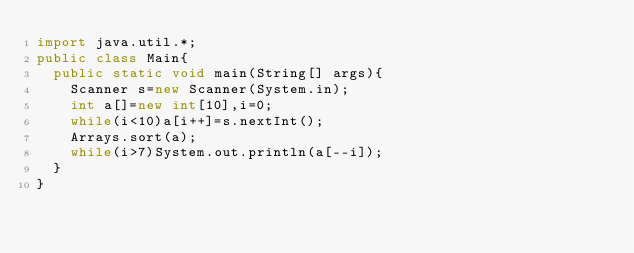<code> <loc_0><loc_0><loc_500><loc_500><_Java_>import java.util.*;
public class Main{
	public static void main(String[] args){
		Scanner s=new Scanner(System.in);
		int a[]=new int[10],i=0;
		while(i<10)a[i++]=s.nextInt();
		Arrays.sort(a);
		while(i>7)System.out.println(a[--i]);
	}
}</code> 